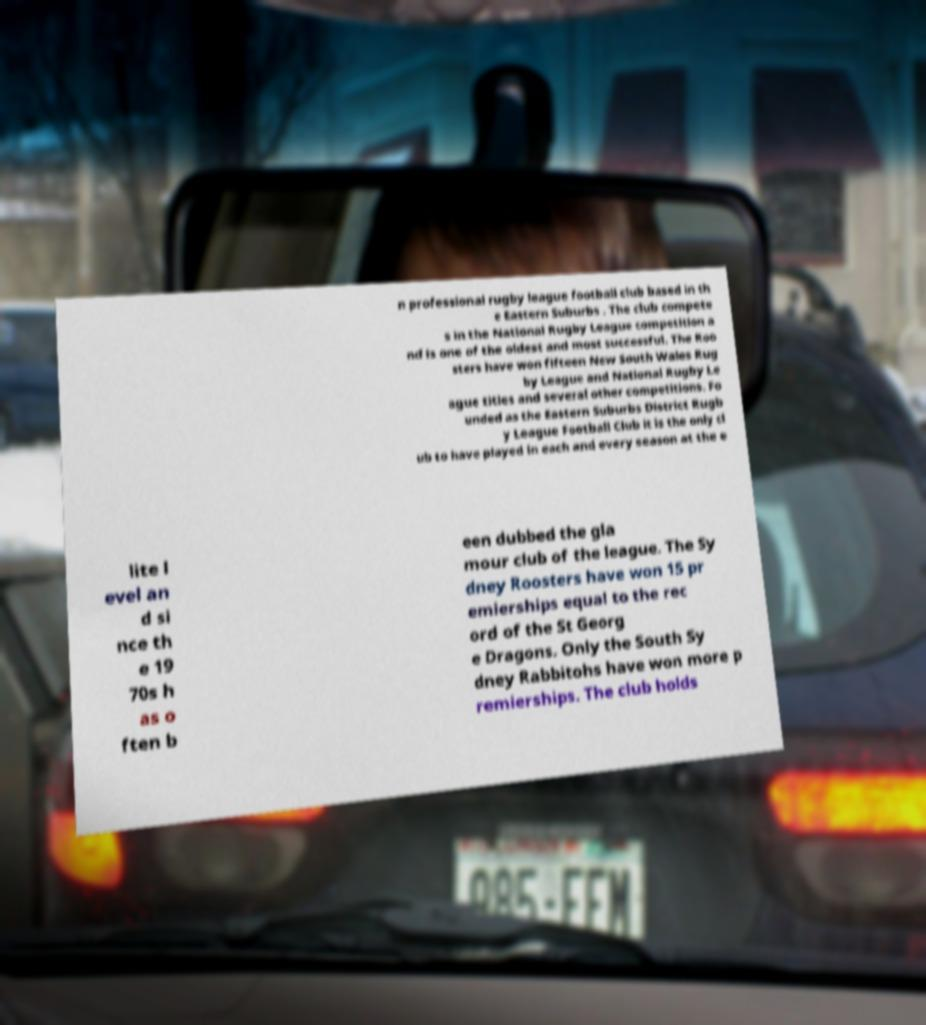Can you read and provide the text displayed in the image?This photo seems to have some interesting text. Can you extract and type it out for me? n professional rugby league football club based in th e Eastern Suburbs . The club compete s in the National Rugby League competition a nd is one of the oldest and most successful. The Roo sters have won fifteen New South Wales Rug by League and National Rugby Le ague titles and several other competitions. Fo unded as the Eastern Suburbs District Rugb y League Football Club it is the only cl ub to have played in each and every season at the e lite l evel an d si nce th e 19 70s h as o ften b een dubbed the gla mour club of the league. The Sy dney Roosters have won 15 pr emierships equal to the rec ord of the St Georg e Dragons. Only the South Sy dney Rabbitohs have won more p remierships. The club holds 